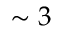<formula> <loc_0><loc_0><loc_500><loc_500>\sim 3</formula> 